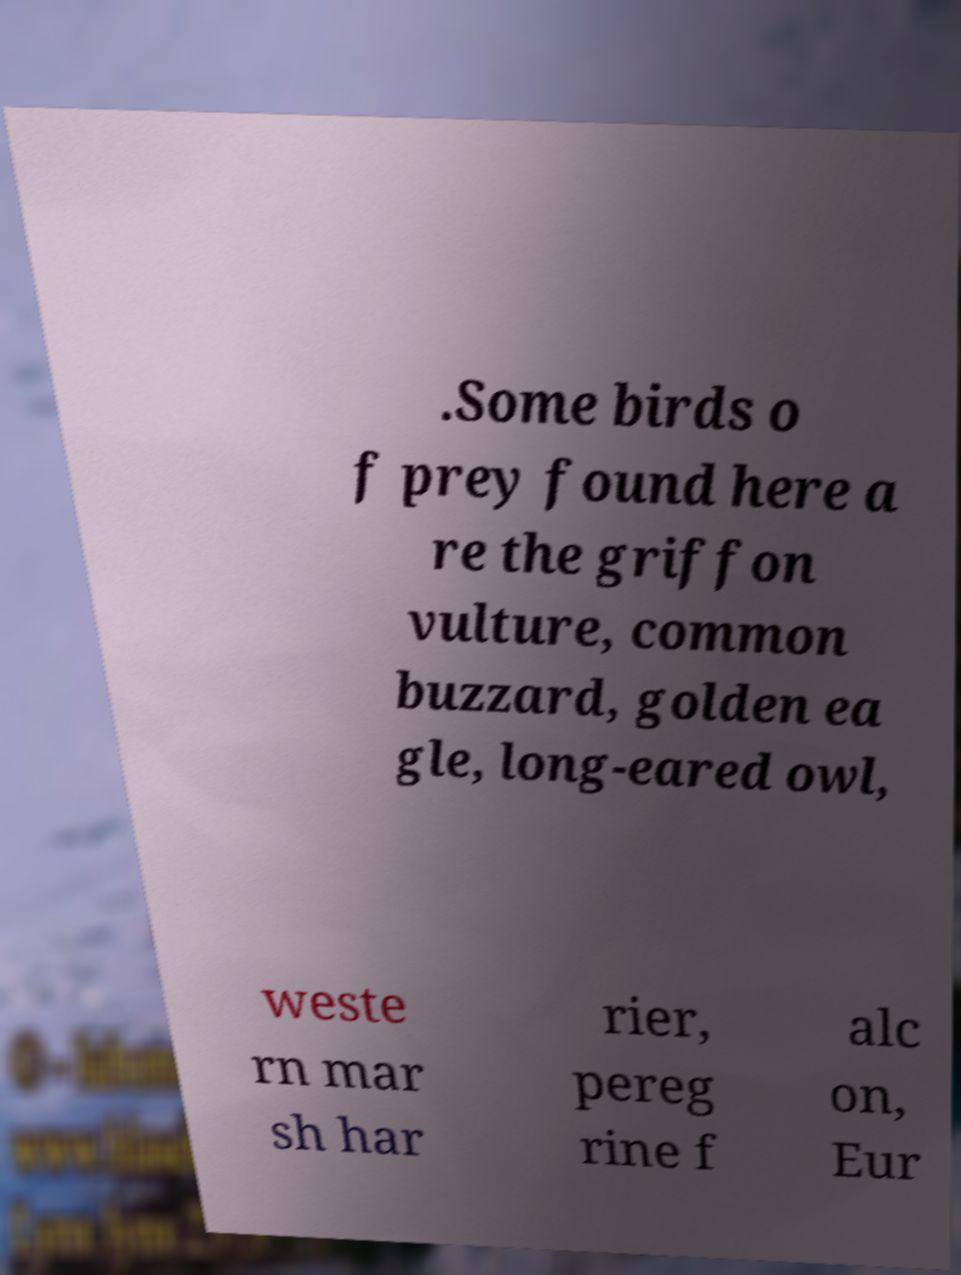Could you extract and type out the text from this image? .Some birds o f prey found here a re the griffon vulture, common buzzard, golden ea gle, long-eared owl, weste rn mar sh har rier, pereg rine f alc on, Eur 